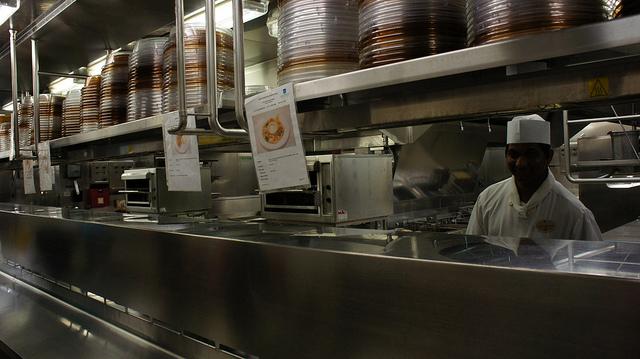Are there stripes on the containers behind the man?
Be succinct. Yes. Is the man wearing a hat?
Be succinct. Yes. What is the big silver thing?
Keep it brief. Counter. Is the counter shiny?
Keep it brief. Yes. Is it day time or night time?
Short answer required. Night. Is this a shoe store?
Keep it brief. No. 